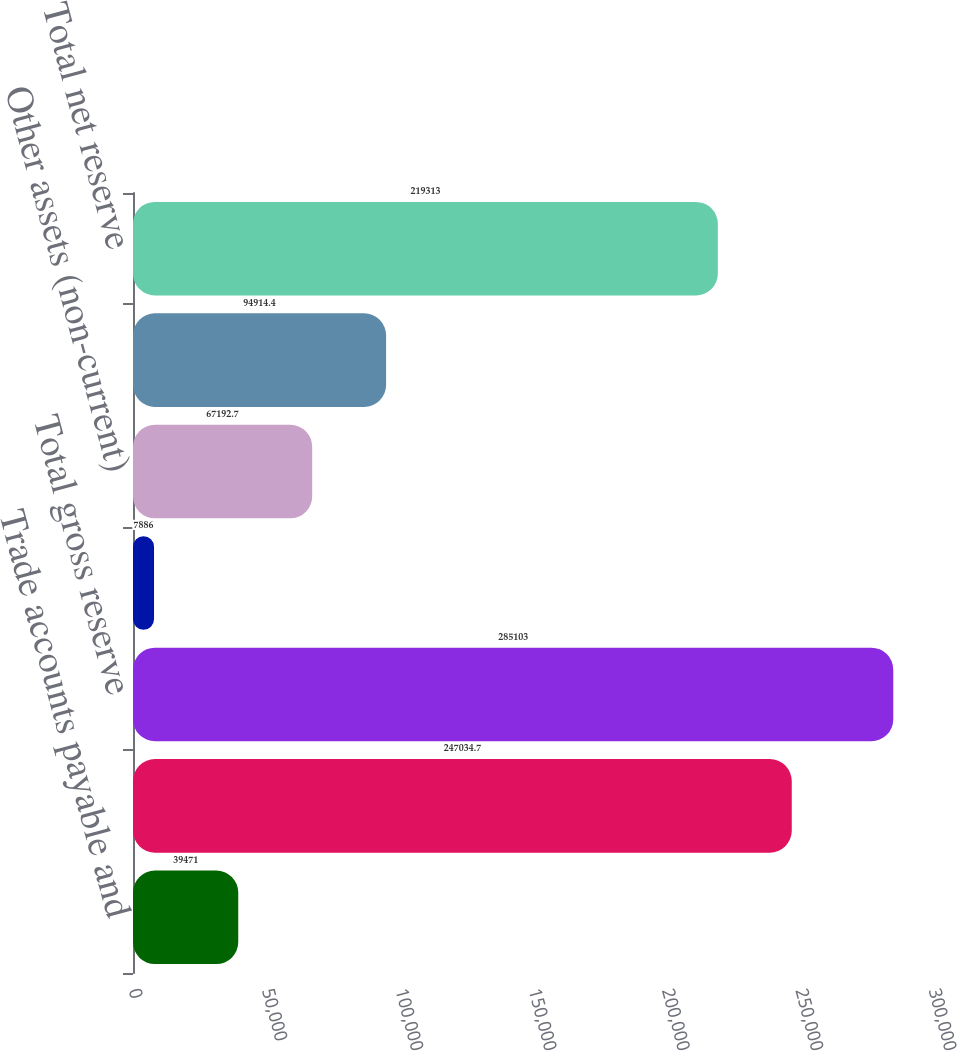Convert chart to OTSL. <chart><loc_0><loc_0><loc_500><loc_500><bar_chart><fcel>Trade accounts payable and<fcel>Other long-term liabilities<fcel>Total gross reserve<fcel>Other current assets (current)<fcel>Other assets (non-current)<fcel>Total recoverables from<fcel>Total net reserve<nl><fcel>39471<fcel>247035<fcel>285103<fcel>7886<fcel>67192.7<fcel>94914.4<fcel>219313<nl></chart> 